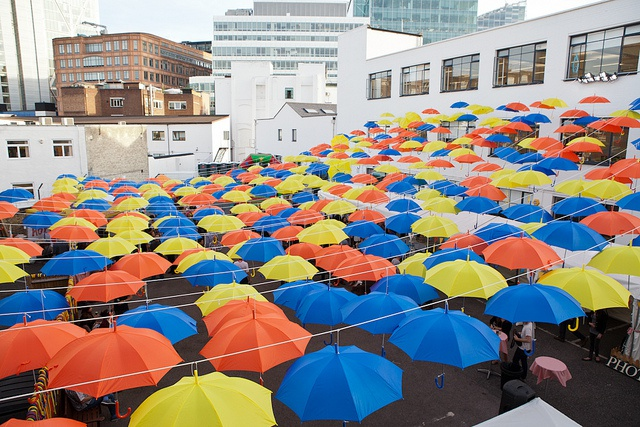Describe the objects in this image and their specific colors. I can see umbrella in white, khaki, blue, red, and salmon tones, umbrella in white, blue, gray, and navy tones, umbrella in white, red, and salmon tones, umbrella in white, blue, gray, and navy tones, and dining table in white, darkgray, lightgray, and black tones in this image. 